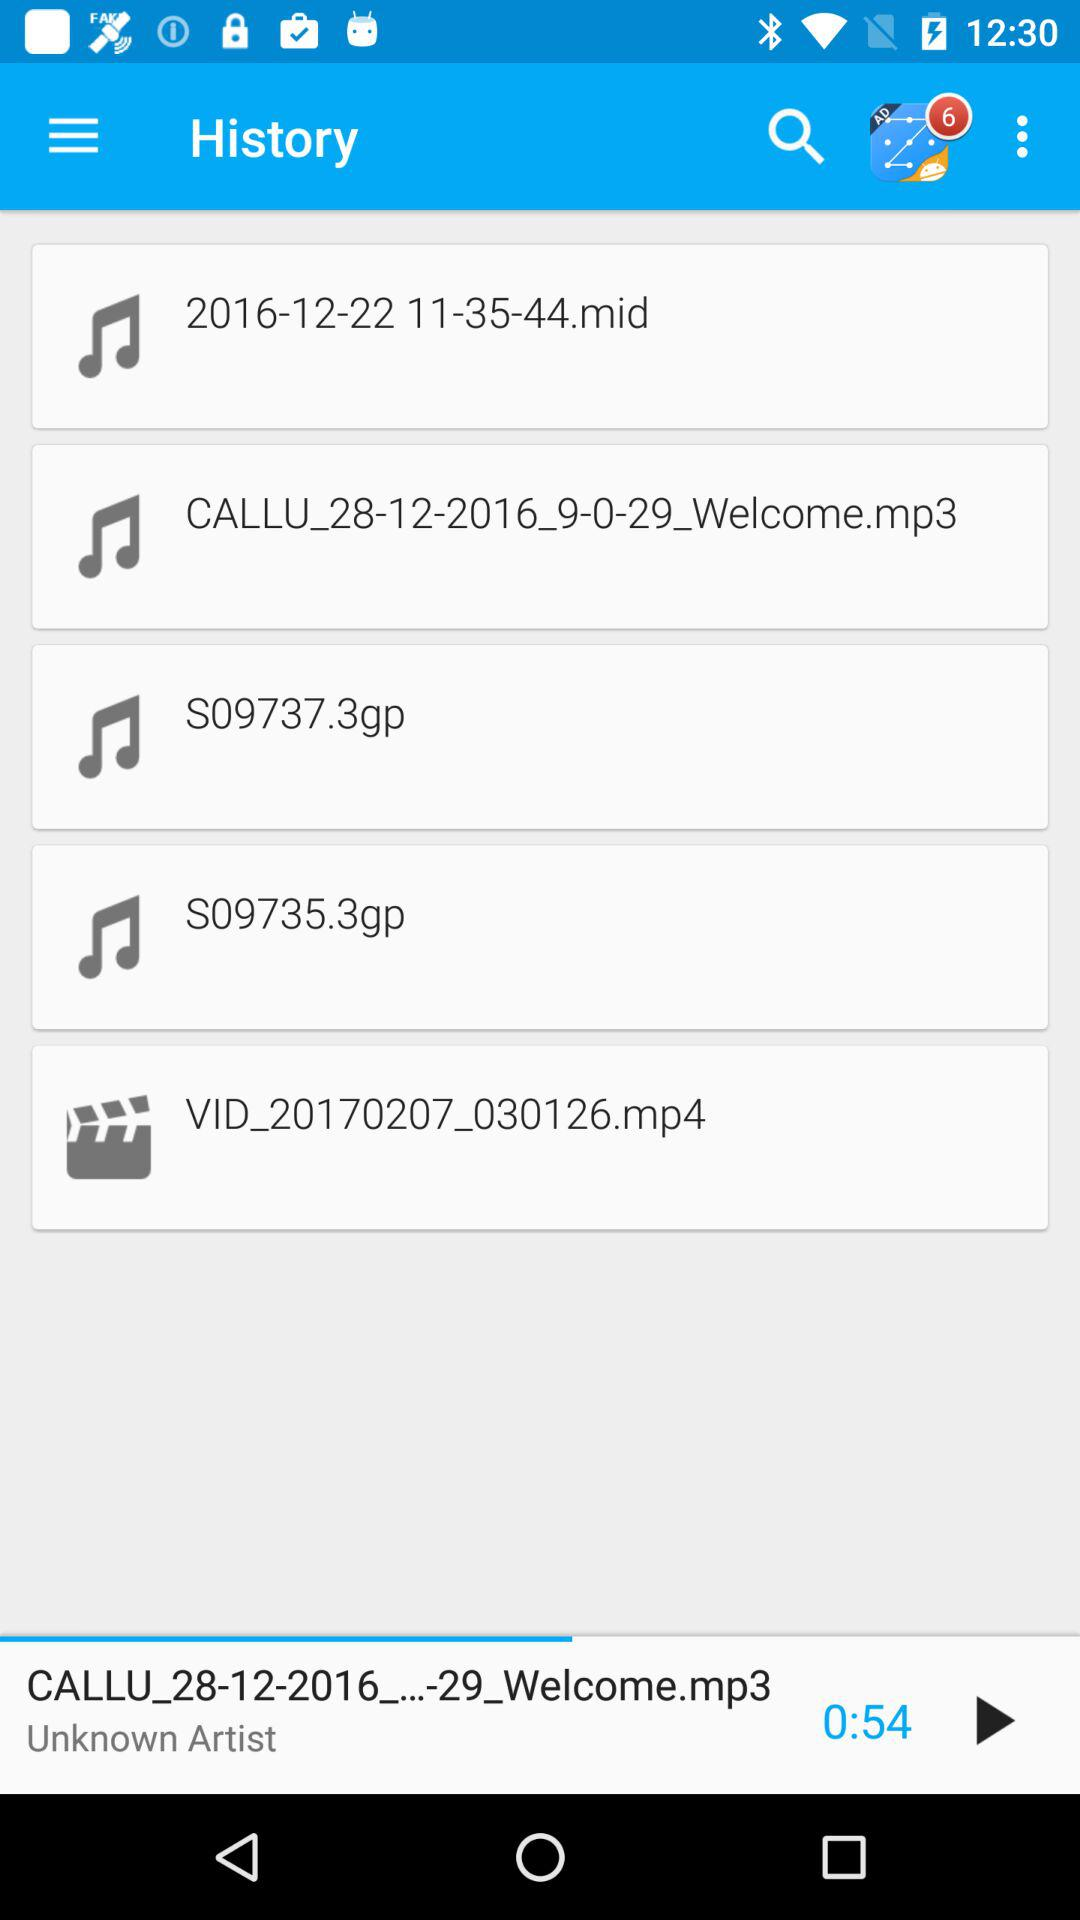How many notifications are there? There are 6 notifications. 